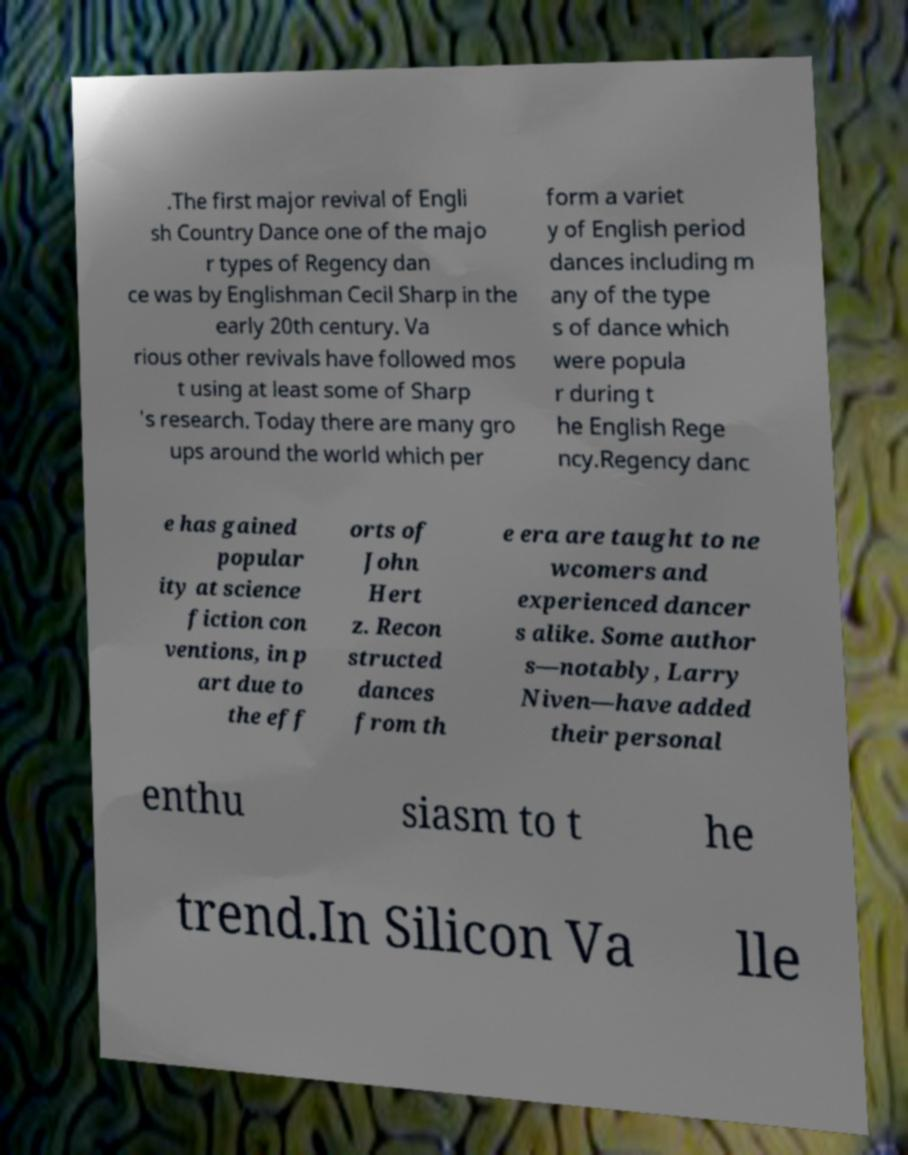Could you assist in decoding the text presented in this image and type it out clearly? .The first major revival of Engli sh Country Dance one of the majo r types of Regency dan ce was by Englishman Cecil Sharp in the early 20th century. Va rious other revivals have followed mos t using at least some of Sharp 's research. Today there are many gro ups around the world which per form a variet y of English period dances including m any of the type s of dance which were popula r during t he English Rege ncy.Regency danc e has gained popular ity at science fiction con ventions, in p art due to the eff orts of John Hert z. Recon structed dances from th e era are taught to ne wcomers and experienced dancer s alike. Some author s—notably, Larry Niven—have added their personal enthu siasm to t he trend.In Silicon Va lle 